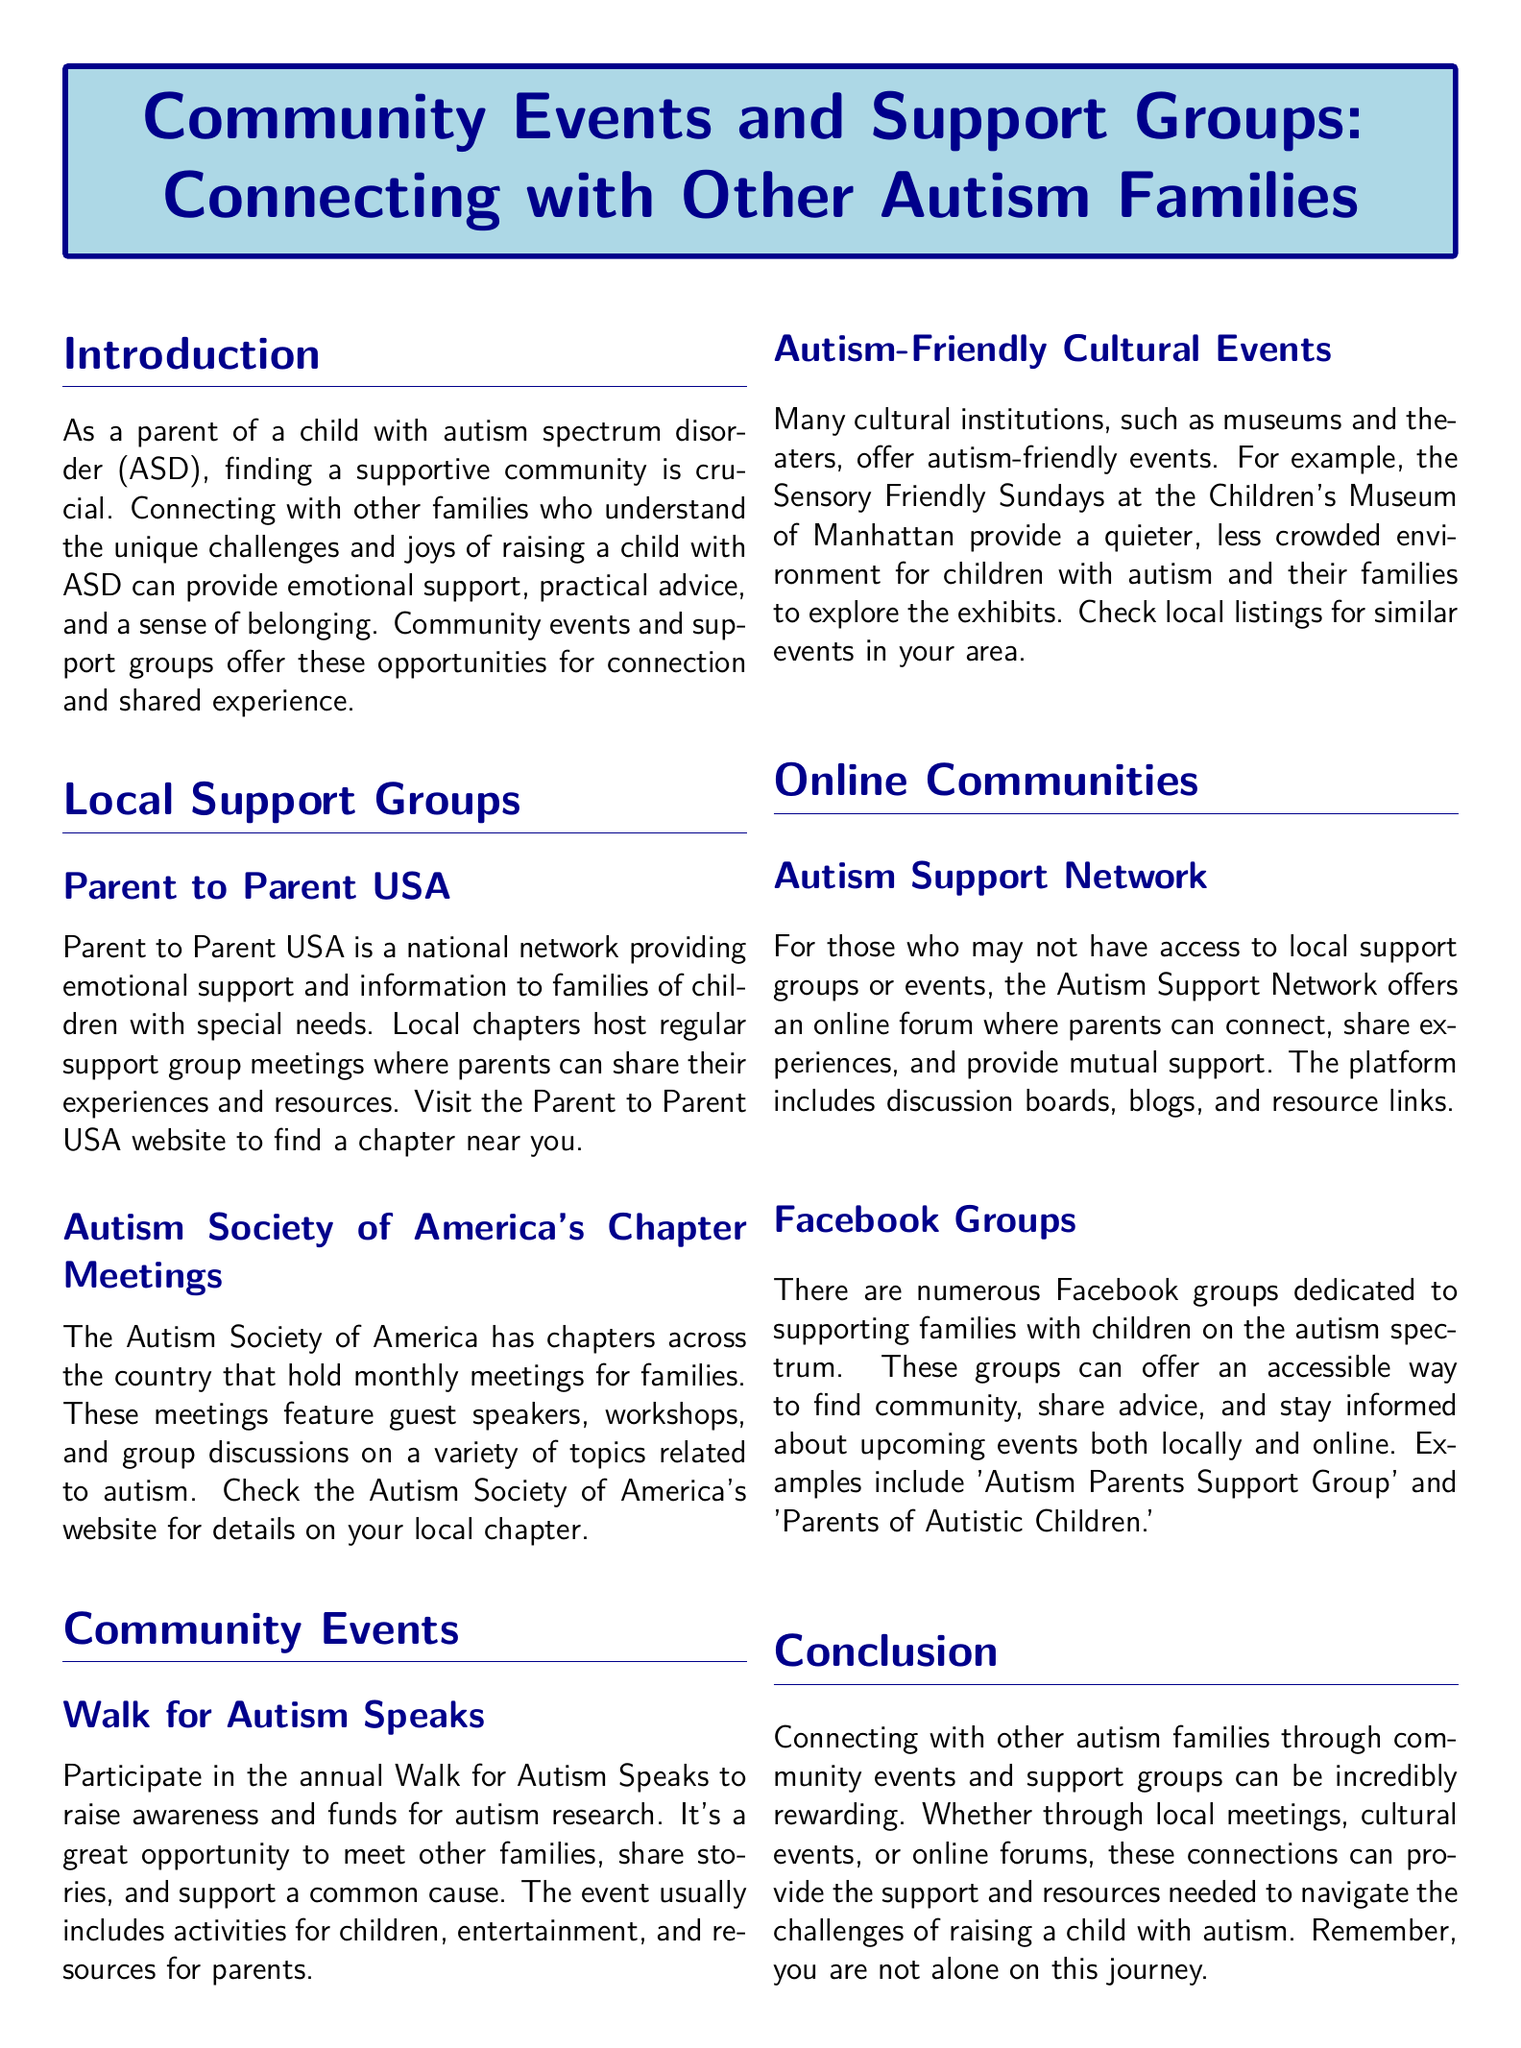What is the main topic of the document? The document focuses on connecting families affected by autism through community events and support groups.
Answer: Community Events and Support Groups: Connecting with Other Autism Families What organization hosts Parent to Parent support groups? The document mentions Parent to Parent USA as a key organization that supports families of children with special needs.
Answer: Parent to Parent USA What event raises awareness and funds for autism research? The document describes the "Walk for Autism Speaks" as an event that serves this purpose.
Answer: Walk for Autism Speaks How often do the Autism Society of America hold chapter meetings? According to the document, these meetings are held monthly for families.
Answer: Monthly What is one type of autism-friendly event mentioned? The document mentions Sensory Friendly Sundays at the Children's Museum of Manhattan as an autism-friendly cultural event.
Answer: Sensory Friendly Sundays What type of support can the Autism Support Network provide? The document states that the Autism Support Network offers an online forum for parents to connect and share experiences.
Answer: Online forum How can Facebook groups help autism families? The document indicates that Facebook groups provide accessible ways to find community and share advice.
Answer: Find community and share advice What is the conclusion of the document about connecting with other families? The document concludes that connecting with other autism families can be rewarding and supportive.
Answer: Incredibly rewarding 